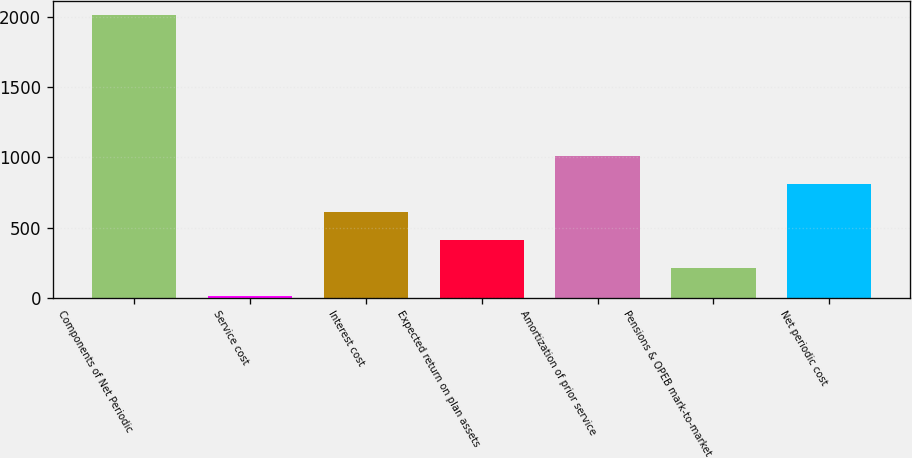Convert chart. <chart><loc_0><loc_0><loc_500><loc_500><bar_chart><fcel>Components of Net Periodic<fcel>Service cost<fcel>Interest cost<fcel>Expected return on plan assets<fcel>Amortization of prior service<fcel>Pensions & OPEB mark-to-market<fcel>Net periodic cost<nl><fcel>2010<fcel>10<fcel>610<fcel>410<fcel>1010<fcel>210<fcel>810<nl></chart> 